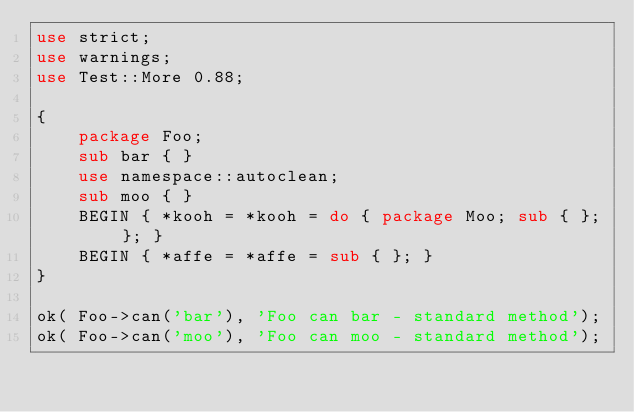<code> <loc_0><loc_0><loc_500><loc_500><_Perl_>use strict;
use warnings;
use Test::More 0.88;

{
    package Foo;
    sub bar { }
    use namespace::autoclean;
    sub moo { }
    BEGIN { *kooh = *kooh = do { package Moo; sub { }; }; }
    BEGIN { *affe = *affe = sub { }; }
}

ok( Foo->can('bar'), 'Foo can bar - standard method');
ok( Foo->can('moo'), 'Foo can moo - standard method');</code> 